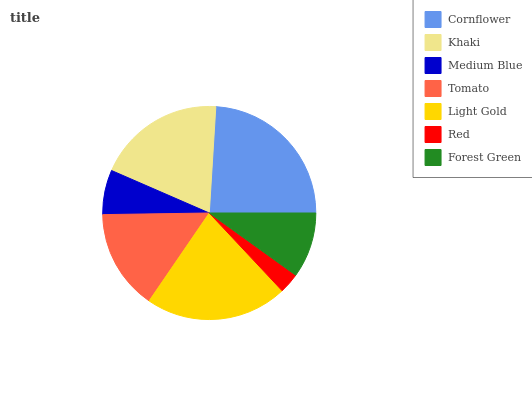Is Red the minimum?
Answer yes or no. Yes. Is Cornflower the maximum?
Answer yes or no. Yes. Is Khaki the minimum?
Answer yes or no. No. Is Khaki the maximum?
Answer yes or no. No. Is Cornflower greater than Khaki?
Answer yes or no. Yes. Is Khaki less than Cornflower?
Answer yes or no. Yes. Is Khaki greater than Cornflower?
Answer yes or no. No. Is Cornflower less than Khaki?
Answer yes or no. No. Is Tomato the high median?
Answer yes or no. Yes. Is Tomato the low median?
Answer yes or no. Yes. Is Light Gold the high median?
Answer yes or no. No. Is Light Gold the low median?
Answer yes or no. No. 